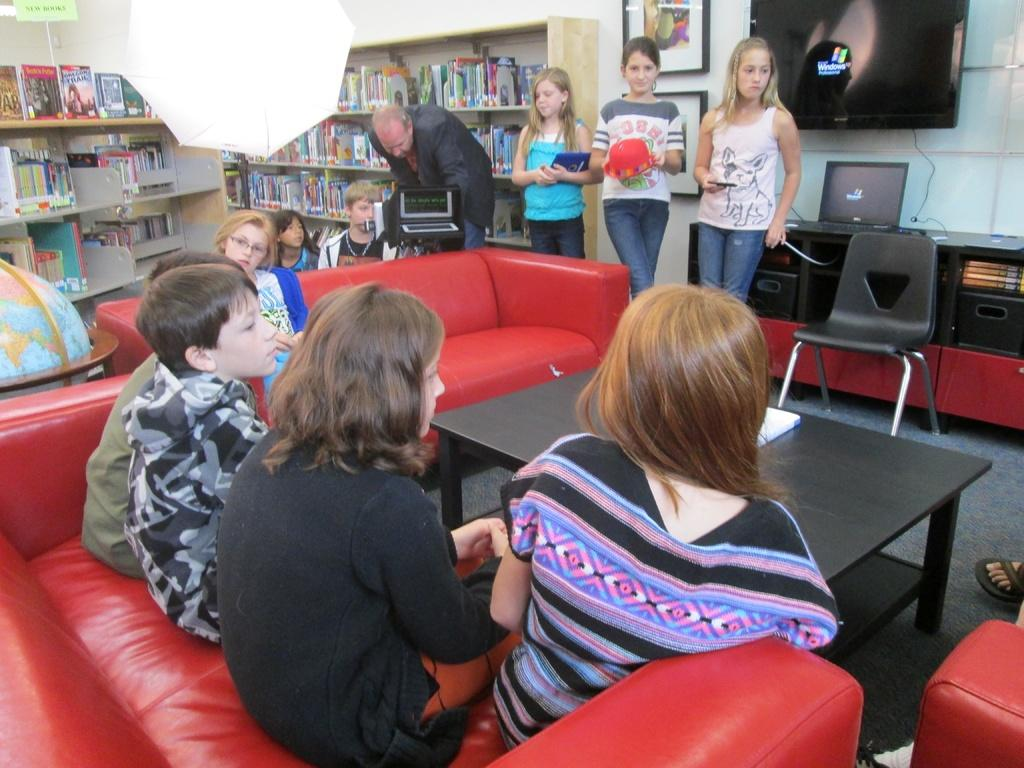<image>
Create a compact narrative representing the image presented. Some teenagers stand near a monitor with the Windows brand on a black screen. 